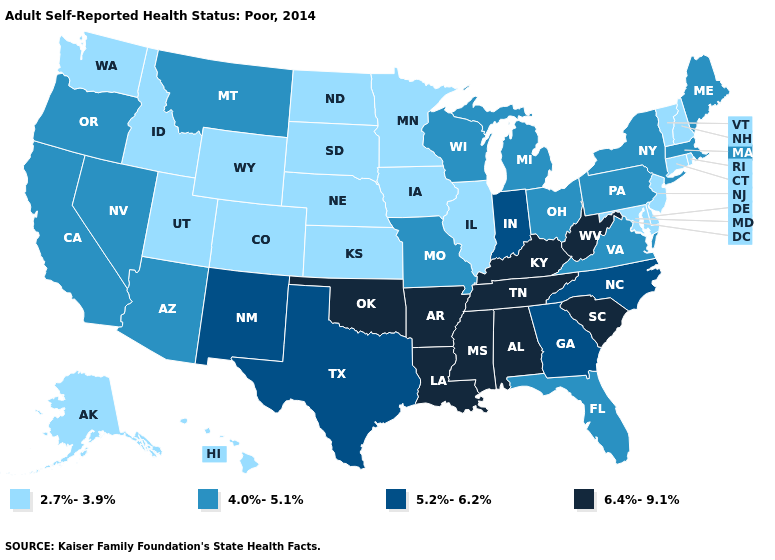How many symbols are there in the legend?
Keep it brief. 4. Name the states that have a value in the range 2.7%-3.9%?
Be succinct. Alaska, Colorado, Connecticut, Delaware, Hawaii, Idaho, Illinois, Iowa, Kansas, Maryland, Minnesota, Nebraska, New Hampshire, New Jersey, North Dakota, Rhode Island, South Dakota, Utah, Vermont, Washington, Wyoming. Name the states that have a value in the range 4.0%-5.1%?
Quick response, please. Arizona, California, Florida, Maine, Massachusetts, Michigan, Missouri, Montana, Nevada, New York, Ohio, Oregon, Pennsylvania, Virginia, Wisconsin. Does West Virginia have the highest value in the USA?
Answer briefly. Yes. What is the value of California?
Be succinct. 4.0%-5.1%. What is the value of Texas?
Give a very brief answer. 5.2%-6.2%. What is the lowest value in states that border Idaho?
Write a very short answer. 2.7%-3.9%. Does New Jersey have the lowest value in the Northeast?
Keep it brief. Yes. Among the states that border Utah , which have the lowest value?
Concise answer only. Colorado, Idaho, Wyoming. What is the value of Oregon?
Write a very short answer. 4.0%-5.1%. Among the states that border Georgia , which have the lowest value?
Be succinct. Florida. Among the states that border South Dakota , does Iowa have the lowest value?
Be succinct. Yes. Among the states that border New Mexico , does Utah have the lowest value?
Be succinct. Yes. Does New Mexico have the highest value in the West?
Give a very brief answer. Yes. 